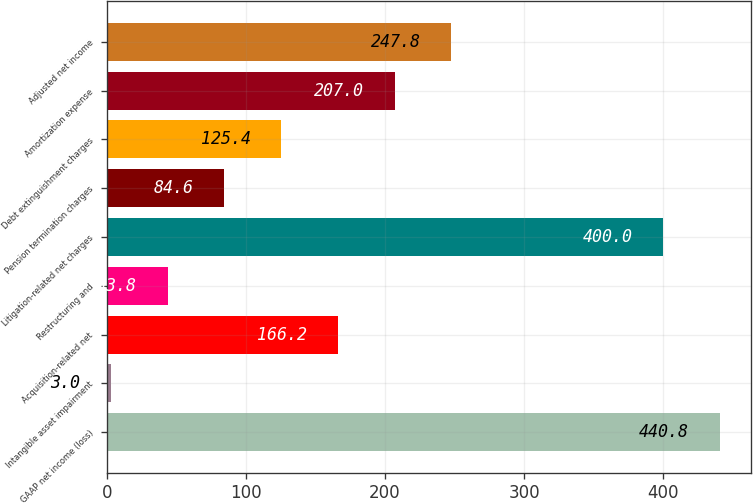Convert chart. <chart><loc_0><loc_0><loc_500><loc_500><bar_chart><fcel>GAAP net income (loss)<fcel>Intangible asset impairment<fcel>Acquisition-related net<fcel>Restructuring and<fcel>Litigation-related net charges<fcel>Pension termination charges<fcel>Debt extinguishment charges<fcel>Amortization expense<fcel>Adjusted net income<nl><fcel>440.8<fcel>3<fcel>166.2<fcel>43.8<fcel>400<fcel>84.6<fcel>125.4<fcel>207<fcel>247.8<nl></chart> 